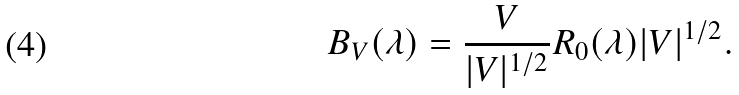Convert formula to latex. <formula><loc_0><loc_0><loc_500><loc_500>B _ { V } ( \lambda ) = \frac { V } { | V | ^ { 1 / 2 } } R _ { 0 } ( \lambda ) | V | ^ { 1 / 2 } .</formula> 